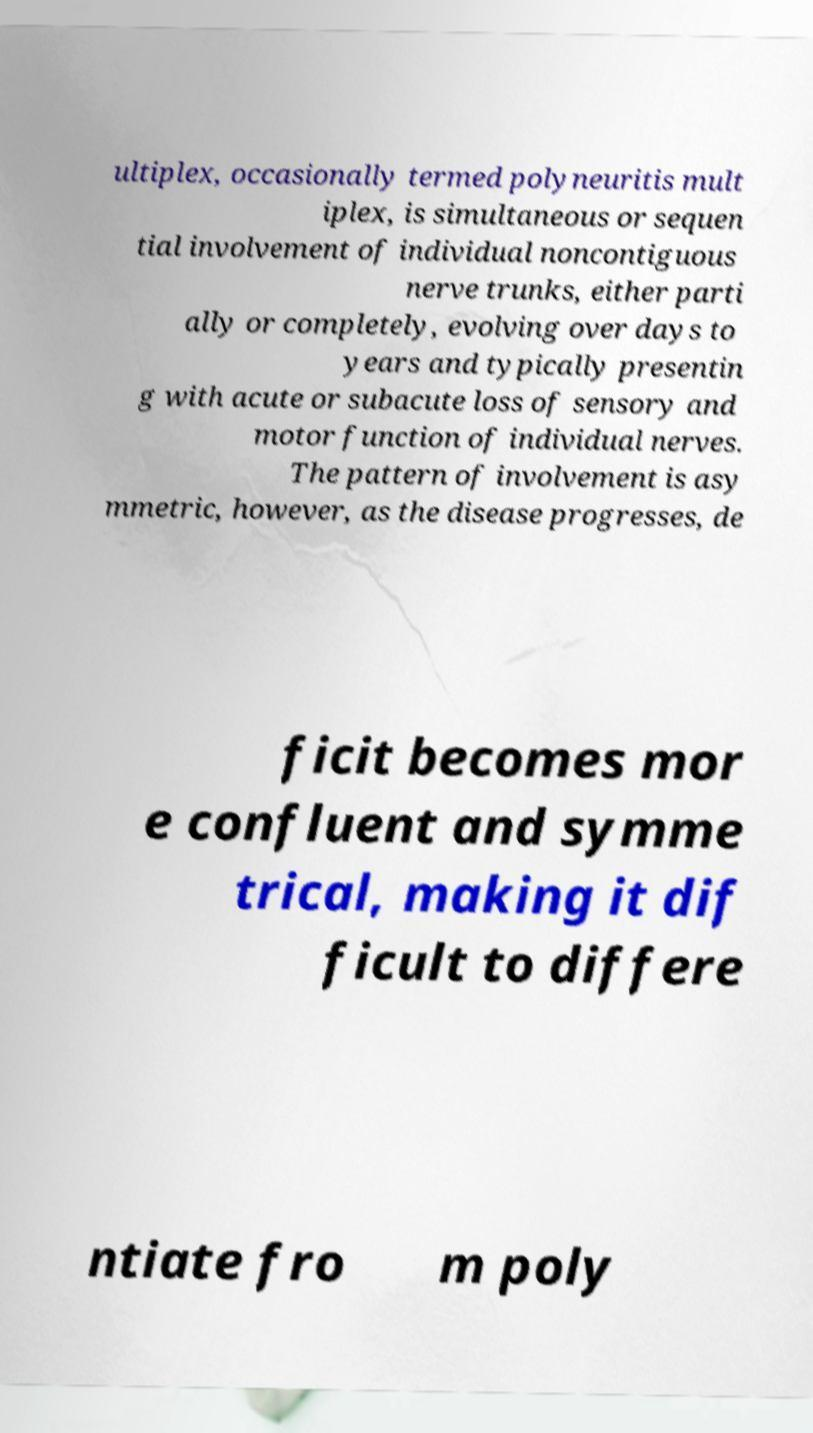Could you extract and type out the text from this image? ultiplex, occasionally termed polyneuritis mult iplex, is simultaneous or sequen tial involvement of individual noncontiguous nerve trunks, either parti ally or completely, evolving over days to years and typically presentin g with acute or subacute loss of sensory and motor function of individual nerves. The pattern of involvement is asy mmetric, however, as the disease progresses, de ficit becomes mor e confluent and symme trical, making it dif ficult to differe ntiate fro m poly 